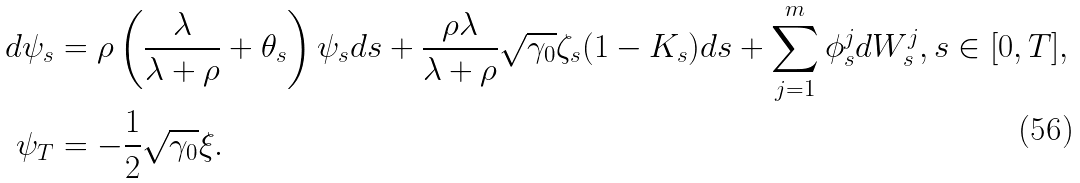Convert formula to latex. <formula><loc_0><loc_0><loc_500><loc_500>d \psi _ { s } & = \rho \left ( \frac { \lambda } { \lambda + \rho } + \theta _ { s } \right ) \psi _ { s } d s + \frac { \rho \lambda } { \lambda + \rho } \sqrt { \gamma _ { 0 } } \zeta _ { s } ( 1 - K _ { s } ) d s + \sum _ { j = 1 } ^ { m } \phi _ { s } ^ { j } d W _ { s } ^ { j } , s \in [ 0 , T ] , \\ \psi _ { T } & = - \frac { 1 } { 2 } \sqrt { \gamma _ { 0 } } \xi .</formula> 